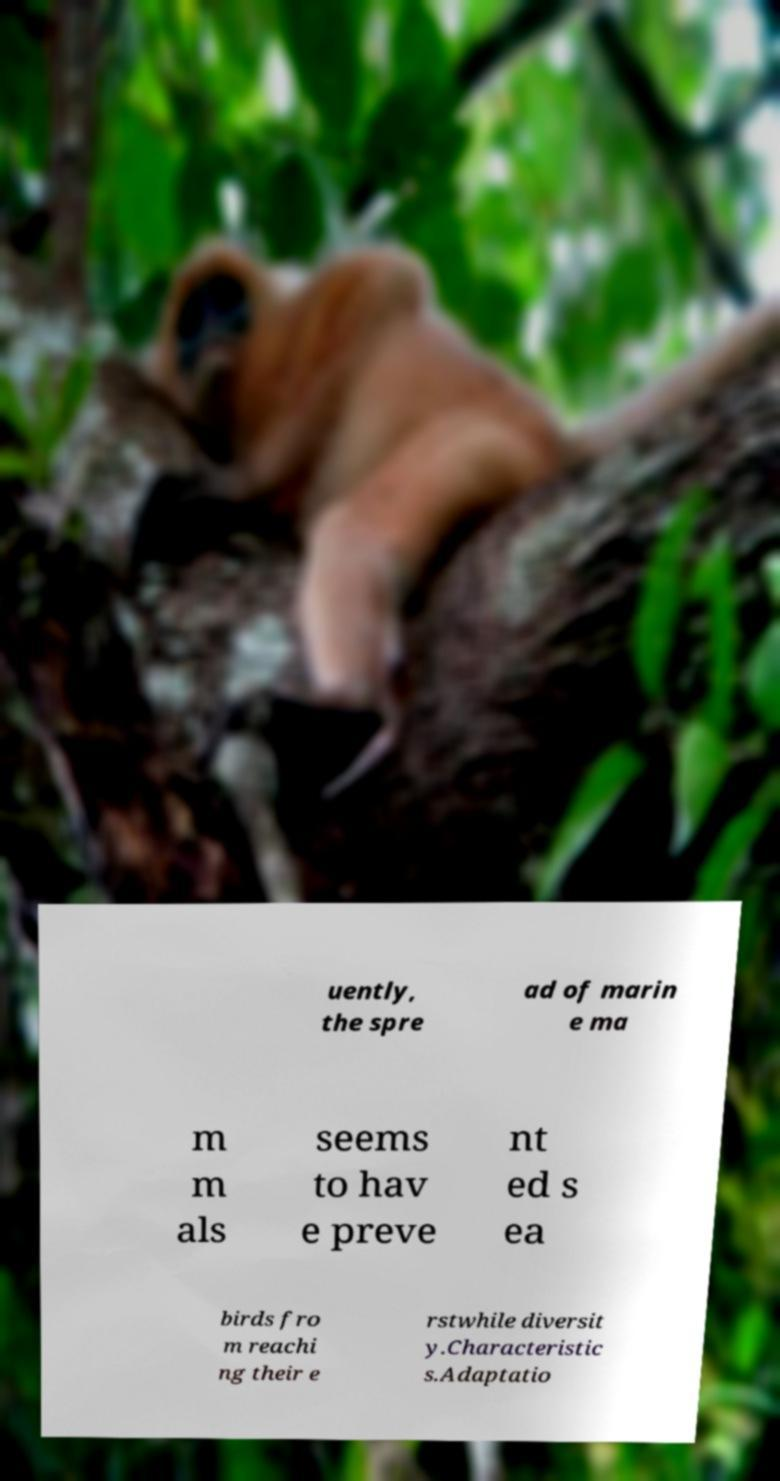I need the written content from this picture converted into text. Can you do that? uently, the spre ad of marin e ma m m als seems to hav e preve nt ed s ea birds fro m reachi ng their e rstwhile diversit y.Characteristic s.Adaptatio 